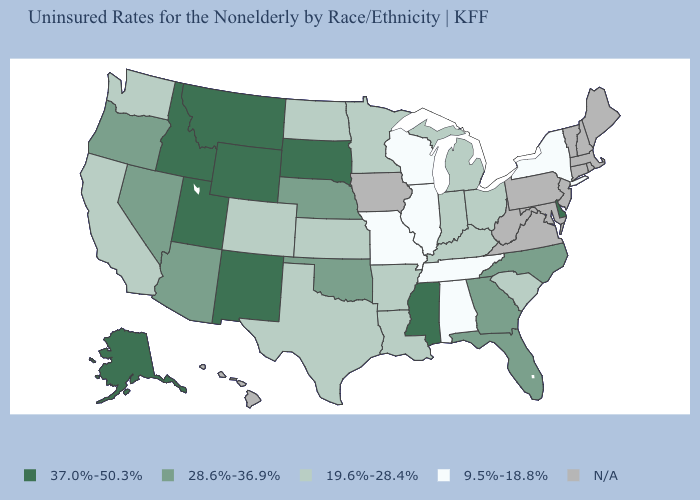Which states have the lowest value in the USA?
Concise answer only. Alabama, Illinois, Missouri, New York, Tennessee, Wisconsin. Does the first symbol in the legend represent the smallest category?
Keep it brief. No. What is the value of New Mexico?
Short answer required. 37.0%-50.3%. Name the states that have a value in the range 9.5%-18.8%?
Short answer required. Alabama, Illinois, Missouri, New York, Tennessee, Wisconsin. What is the value of Tennessee?
Concise answer only. 9.5%-18.8%. Among the states that border Mississippi , which have the lowest value?
Quick response, please. Alabama, Tennessee. What is the value of Washington?
Concise answer only. 19.6%-28.4%. Name the states that have a value in the range N/A?
Give a very brief answer. Connecticut, Hawaii, Iowa, Maine, Maryland, Massachusetts, New Hampshire, New Jersey, Pennsylvania, Rhode Island, Vermont, Virginia, West Virginia. What is the value of New Hampshire?
Give a very brief answer. N/A. Does Mississippi have the highest value in the South?
Write a very short answer. Yes. What is the highest value in states that border Kentucky?
Keep it brief. 19.6%-28.4%. Name the states that have a value in the range 9.5%-18.8%?
Concise answer only. Alabama, Illinois, Missouri, New York, Tennessee, Wisconsin. Among the states that border New Mexico , does Texas have the lowest value?
Give a very brief answer. Yes. What is the value of Oregon?
Concise answer only. 28.6%-36.9%. 